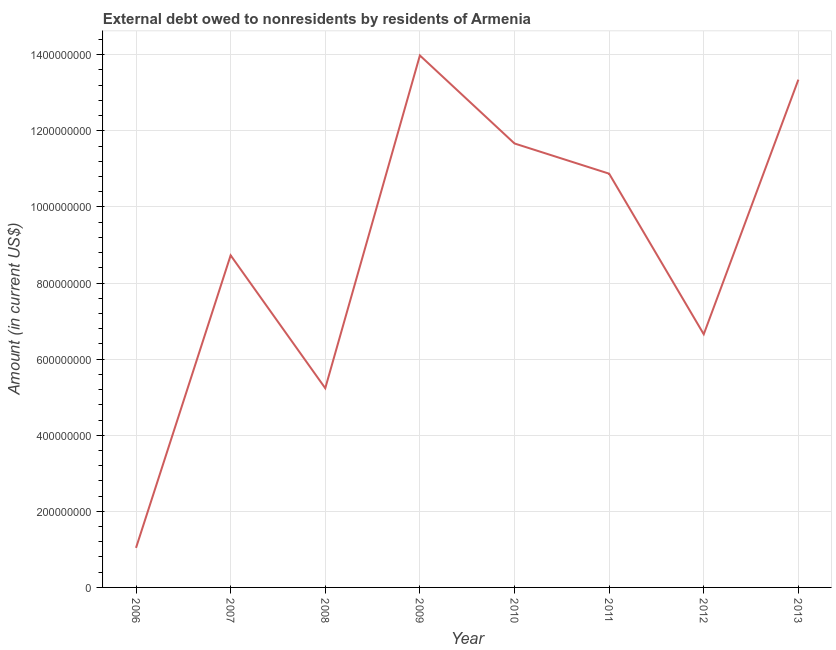What is the debt in 2007?
Provide a succinct answer. 8.73e+08. Across all years, what is the maximum debt?
Provide a short and direct response. 1.40e+09. Across all years, what is the minimum debt?
Offer a terse response. 1.04e+08. What is the sum of the debt?
Your answer should be compact. 7.15e+09. What is the difference between the debt in 2010 and 2012?
Make the answer very short. 5.01e+08. What is the average debt per year?
Your answer should be compact. 8.94e+08. What is the median debt?
Offer a very short reply. 9.80e+08. In how many years, is the debt greater than 160000000 US$?
Your answer should be compact. 7. Do a majority of the years between 2012 and 2007 (inclusive) have debt greater than 720000000 US$?
Your answer should be very brief. Yes. What is the ratio of the debt in 2007 to that in 2012?
Your answer should be compact. 1.31. What is the difference between the highest and the second highest debt?
Offer a terse response. 6.36e+07. Is the sum of the debt in 2010 and 2012 greater than the maximum debt across all years?
Give a very brief answer. Yes. What is the difference between the highest and the lowest debt?
Make the answer very short. 1.29e+09. How many years are there in the graph?
Offer a very short reply. 8. What is the difference between two consecutive major ticks on the Y-axis?
Offer a very short reply. 2.00e+08. Are the values on the major ticks of Y-axis written in scientific E-notation?
Keep it short and to the point. No. Does the graph contain any zero values?
Offer a terse response. No. What is the title of the graph?
Provide a short and direct response. External debt owed to nonresidents by residents of Armenia. What is the label or title of the Y-axis?
Your response must be concise. Amount (in current US$). What is the Amount (in current US$) of 2006?
Your answer should be very brief. 1.04e+08. What is the Amount (in current US$) in 2007?
Your response must be concise. 8.73e+08. What is the Amount (in current US$) of 2008?
Your answer should be very brief. 5.24e+08. What is the Amount (in current US$) in 2009?
Your response must be concise. 1.40e+09. What is the Amount (in current US$) of 2010?
Your answer should be compact. 1.17e+09. What is the Amount (in current US$) of 2011?
Your answer should be very brief. 1.09e+09. What is the Amount (in current US$) in 2012?
Provide a short and direct response. 6.65e+08. What is the Amount (in current US$) of 2013?
Provide a short and direct response. 1.33e+09. What is the difference between the Amount (in current US$) in 2006 and 2007?
Provide a short and direct response. -7.69e+08. What is the difference between the Amount (in current US$) in 2006 and 2008?
Keep it short and to the point. -4.20e+08. What is the difference between the Amount (in current US$) in 2006 and 2009?
Your answer should be very brief. -1.29e+09. What is the difference between the Amount (in current US$) in 2006 and 2010?
Keep it short and to the point. -1.06e+09. What is the difference between the Amount (in current US$) in 2006 and 2011?
Your answer should be compact. -9.83e+08. What is the difference between the Amount (in current US$) in 2006 and 2012?
Offer a very short reply. -5.61e+08. What is the difference between the Amount (in current US$) in 2006 and 2013?
Provide a short and direct response. -1.23e+09. What is the difference between the Amount (in current US$) in 2007 and 2008?
Keep it short and to the point. 3.49e+08. What is the difference between the Amount (in current US$) in 2007 and 2009?
Offer a terse response. -5.25e+08. What is the difference between the Amount (in current US$) in 2007 and 2010?
Provide a short and direct response. -2.94e+08. What is the difference between the Amount (in current US$) in 2007 and 2011?
Your answer should be very brief. -2.15e+08. What is the difference between the Amount (in current US$) in 2007 and 2012?
Your answer should be very brief. 2.07e+08. What is the difference between the Amount (in current US$) in 2007 and 2013?
Keep it short and to the point. -4.62e+08. What is the difference between the Amount (in current US$) in 2008 and 2009?
Your answer should be compact. -8.75e+08. What is the difference between the Amount (in current US$) in 2008 and 2010?
Offer a terse response. -6.43e+08. What is the difference between the Amount (in current US$) in 2008 and 2011?
Make the answer very short. -5.64e+08. What is the difference between the Amount (in current US$) in 2008 and 2012?
Offer a terse response. -1.42e+08. What is the difference between the Amount (in current US$) in 2008 and 2013?
Provide a succinct answer. -8.11e+08. What is the difference between the Amount (in current US$) in 2009 and 2010?
Offer a terse response. 2.31e+08. What is the difference between the Amount (in current US$) in 2009 and 2011?
Keep it short and to the point. 3.11e+08. What is the difference between the Amount (in current US$) in 2009 and 2012?
Offer a terse response. 7.33e+08. What is the difference between the Amount (in current US$) in 2009 and 2013?
Your answer should be very brief. 6.36e+07. What is the difference between the Amount (in current US$) in 2010 and 2011?
Your answer should be compact. 7.94e+07. What is the difference between the Amount (in current US$) in 2010 and 2012?
Ensure brevity in your answer.  5.01e+08. What is the difference between the Amount (in current US$) in 2010 and 2013?
Your response must be concise. -1.68e+08. What is the difference between the Amount (in current US$) in 2011 and 2012?
Offer a very short reply. 4.22e+08. What is the difference between the Amount (in current US$) in 2011 and 2013?
Give a very brief answer. -2.47e+08. What is the difference between the Amount (in current US$) in 2012 and 2013?
Provide a short and direct response. -6.69e+08. What is the ratio of the Amount (in current US$) in 2006 to that in 2007?
Ensure brevity in your answer.  0.12. What is the ratio of the Amount (in current US$) in 2006 to that in 2008?
Offer a terse response. 0.2. What is the ratio of the Amount (in current US$) in 2006 to that in 2009?
Offer a terse response. 0.07. What is the ratio of the Amount (in current US$) in 2006 to that in 2010?
Ensure brevity in your answer.  0.09. What is the ratio of the Amount (in current US$) in 2006 to that in 2011?
Give a very brief answer. 0.1. What is the ratio of the Amount (in current US$) in 2006 to that in 2012?
Ensure brevity in your answer.  0.16. What is the ratio of the Amount (in current US$) in 2006 to that in 2013?
Your response must be concise. 0.08. What is the ratio of the Amount (in current US$) in 2007 to that in 2008?
Offer a terse response. 1.67. What is the ratio of the Amount (in current US$) in 2007 to that in 2009?
Your response must be concise. 0.62. What is the ratio of the Amount (in current US$) in 2007 to that in 2010?
Offer a very short reply. 0.75. What is the ratio of the Amount (in current US$) in 2007 to that in 2011?
Offer a very short reply. 0.8. What is the ratio of the Amount (in current US$) in 2007 to that in 2012?
Offer a very short reply. 1.31. What is the ratio of the Amount (in current US$) in 2007 to that in 2013?
Your answer should be very brief. 0.65. What is the ratio of the Amount (in current US$) in 2008 to that in 2009?
Your answer should be compact. 0.37. What is the ratio of the Amount (in current US$) in 2008 to that in 2010?
Make the answer very short. 0.45. What is the ratio of the Amount (in current US$) in 2008 to that in 2011?
Ensure brevity in your answer.  0.48. What is the ratio of the Amount (in current US$) in 2008 to that in 2012?
Your answer should be very brief. 0.79. What is the ratio of the Amount (in current US$) in 2008 to that in 2013?
Give a very brief answer. 0.39. What is the ratio of the Amount (in current US$) in 2009 to that in 2010?
Make the answer very short. 1.2. What is the ratio of the Amount (in current US$) in 2009 to that in 2011?
Offer a terse response. 1.29. What is the ratio of the Amount (in current US$) in 2009 to that in 2012?
Offer a terse response. 2.1. What is the ratio of the Amount (in current US$) in 2009 to that in 2013?
Keep it short and to the point. 1.05. What is the ratio of the Amount (in current US$) in 2010 to that in 2011?
Your response must be concise. 1.07. What is the ratio of the Amount (in current US$) in 2010 to that in 2012?
Give a very brief answer. 1.75. What is the ratio of the Amount (in current US$) in 2010 to that in 2013?
Your answer should be very brief. 0.87. What is the ratio of the Amount (in current US$) in 2011 to that in 2012?
Make the answer very short. 1.63. What is the ratio of the Amount (in current US$) in 2011 to that in 2013?
Offer a terse response. 0.81. What is the ratio of the Amount (in current US$) in 2012 to that in 2013?
Offer a very short reply. 0.5. 